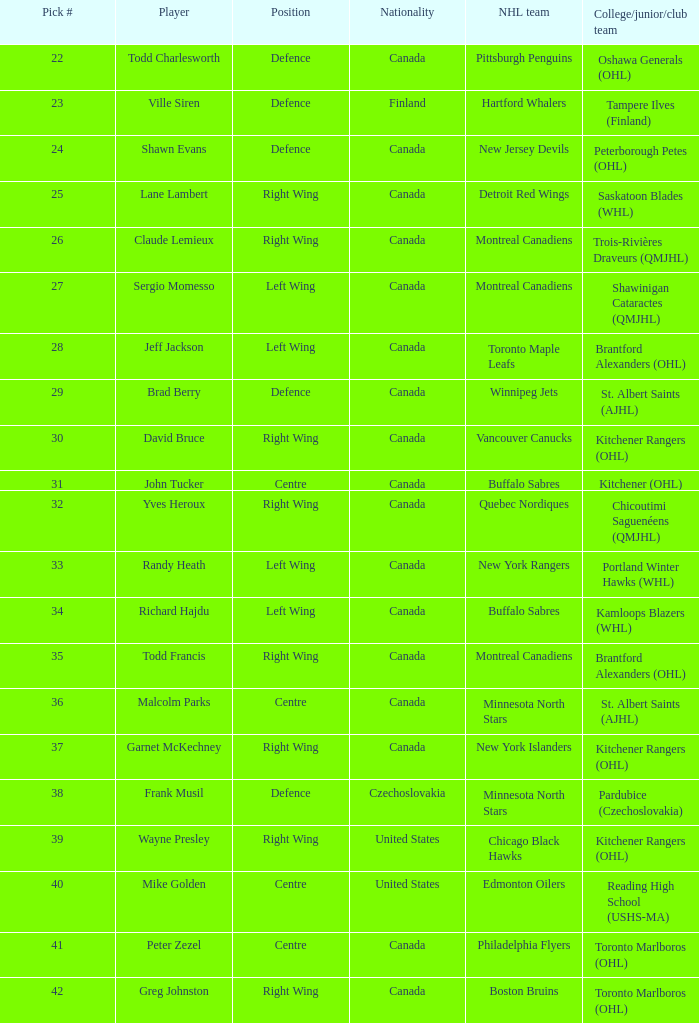What is the nhl team when the college, junior, club team is toronto marlboros (ohl) and the position is centre? Philadelphia Flyers. 